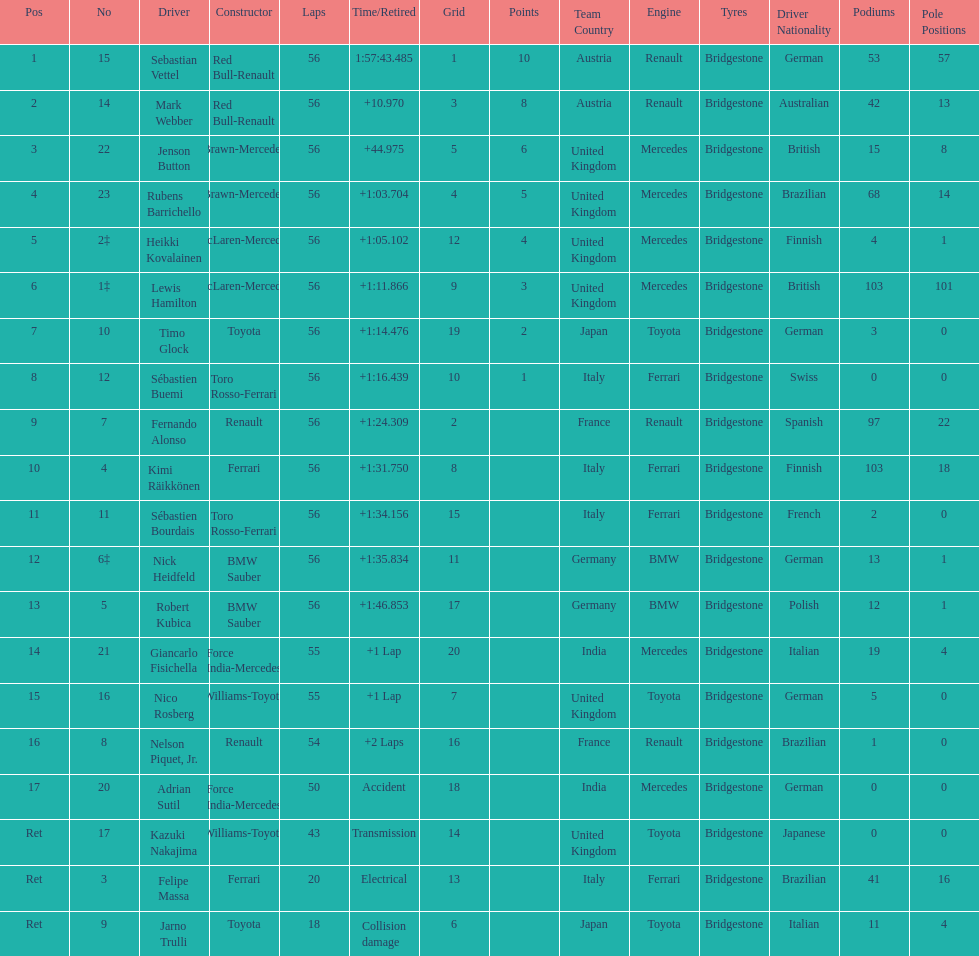What driver was last on the list? Jarno Trulli. 